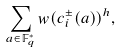<formula> <loc_0><loc_0><loc_500><loc_500>\sum _ { a \in \mathbb { F } _ { q } ^ { * } } w ( c _ { i } ^ { \pm } ( a ) ) ^ { h } ,</formula> 